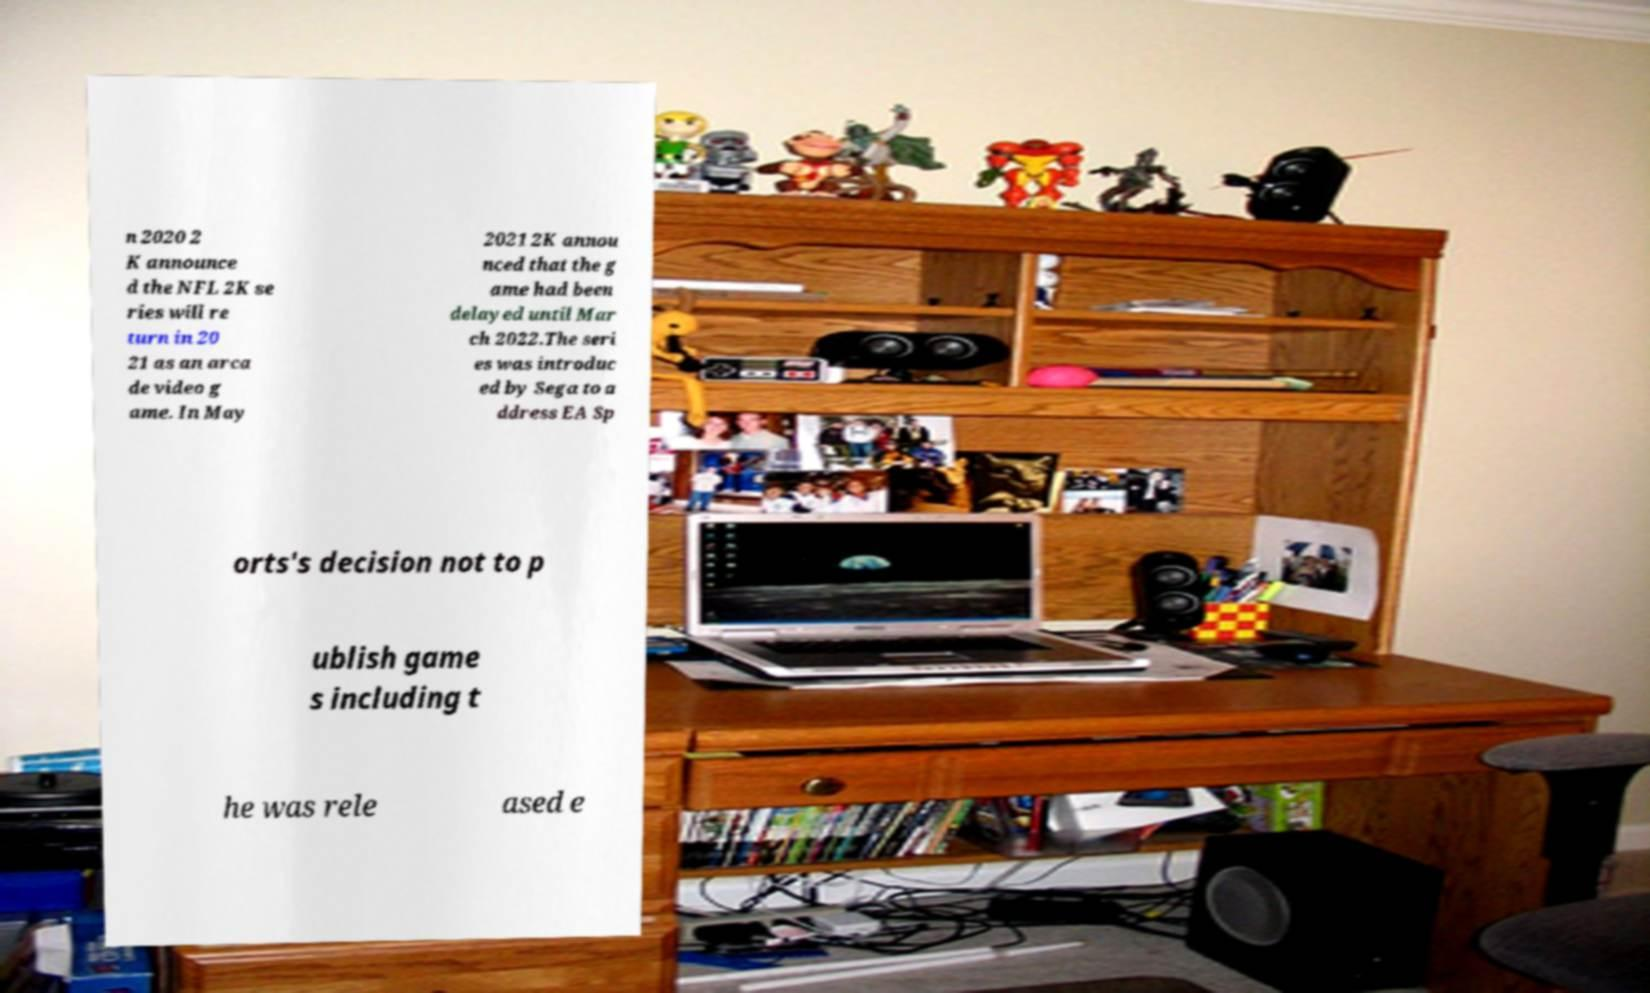Could you extract and type out the text from this image? n 2020 2 K announce d the NFL 2K se ries will re turn in 20 21 as an arca de video g ame. In May 2021 2K annou nced that the g ame had been delayed until Mar ch 2022.The seri es was introduc ed by Sega to a ddress EA Sp orts's decision not to p ublish game s including t he was rele ased e 